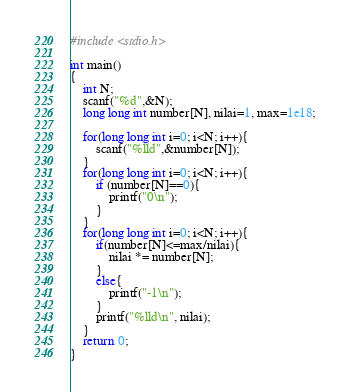<code> <loc_0><loc_0><loc_500><loc_500><_C_>#include <stdio.h>

int main()
{
	int N;
	scanf("%d",&N);
	long long int number[N], nilai=1, max=1e18;
	
	for(long long int i=0; i<N; i++){
		scanf("%lld",&number[N]);
	}
	for(long long int i=0; i<N; i++){
		if (number[N]==0){
			printf("0\n");
		}
	}
	for(long long int i=0; i<N; i++){
		if(number[N]<=max/nilai){
			nilai *= number[N];
		}
		else{
			printf("-1\n");
		}
		printf("%lld\n", nilai);
	}
	return 0;
}</code> 